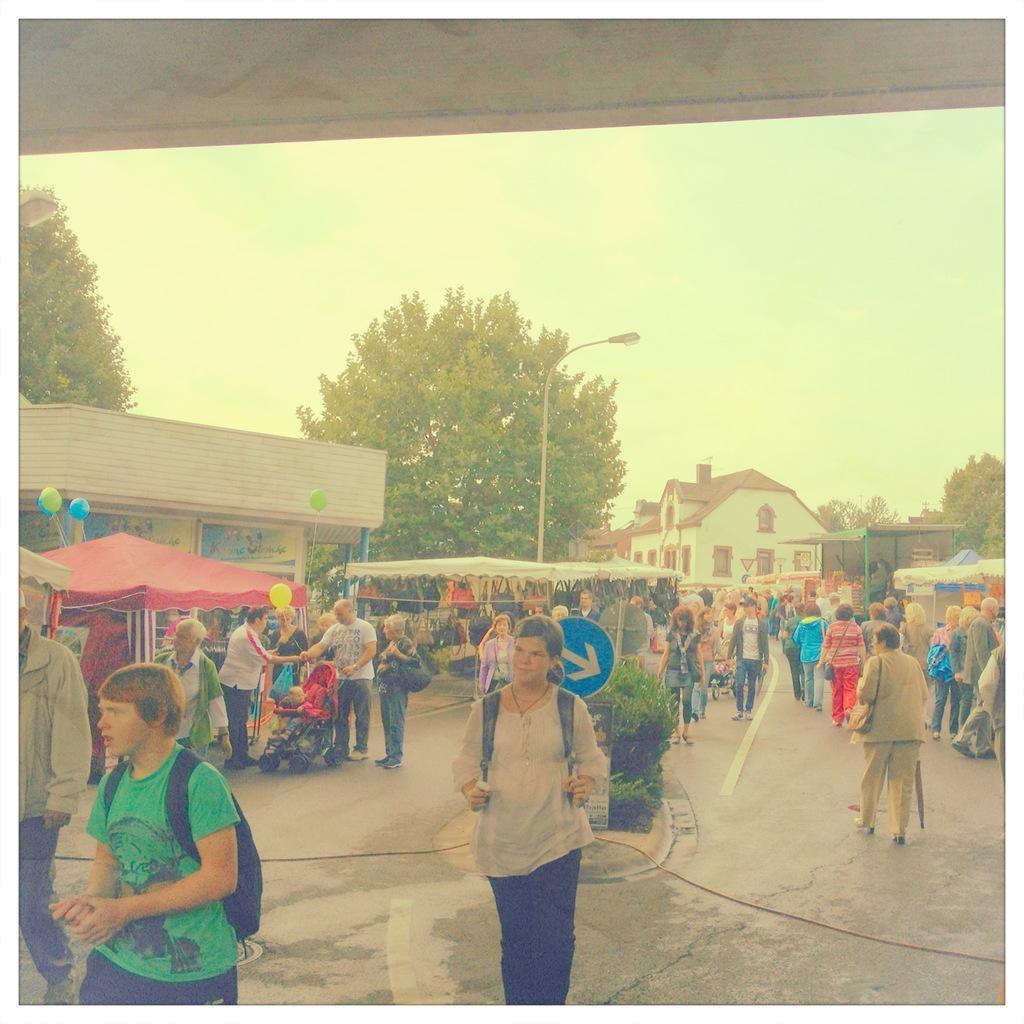Describe this image in one or two sentences. In this image I can see number of people on the road, I can also see few of them are carrying bags. In the centre I can see a blue sign board, few plants and in the background I can see few stalls, few balloons, few buildings, few trees, a pole, a street light and the sky. I can also see a stroller on the left side and in it I can see a baby. 